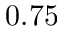Convert formula to latex. <formula><loc_0><loc_0><loc_500><loc_500>0 . 7 5</formula> 